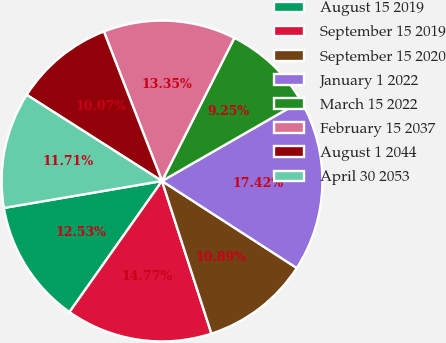Convert chart to OTSL. <chart><loc_0><loc_0><loc_500><loc_500><pie_chart><fcel>August 15 2019<fcel>September 15 2019<fcel>September 15 2020<fcel>January 1 2022<fcel>March 15 2022<fcel>February 15 2037<fcel>August 1 2044<fcel>April 30 2053<nl><fcel>12.53%<fcel>14.77%<fcel>10.89%<fcel>17.42%<fcel>9.25%<fcel>13.35%<fcel>10.07%<fcel>11.71%<nl></chart> 